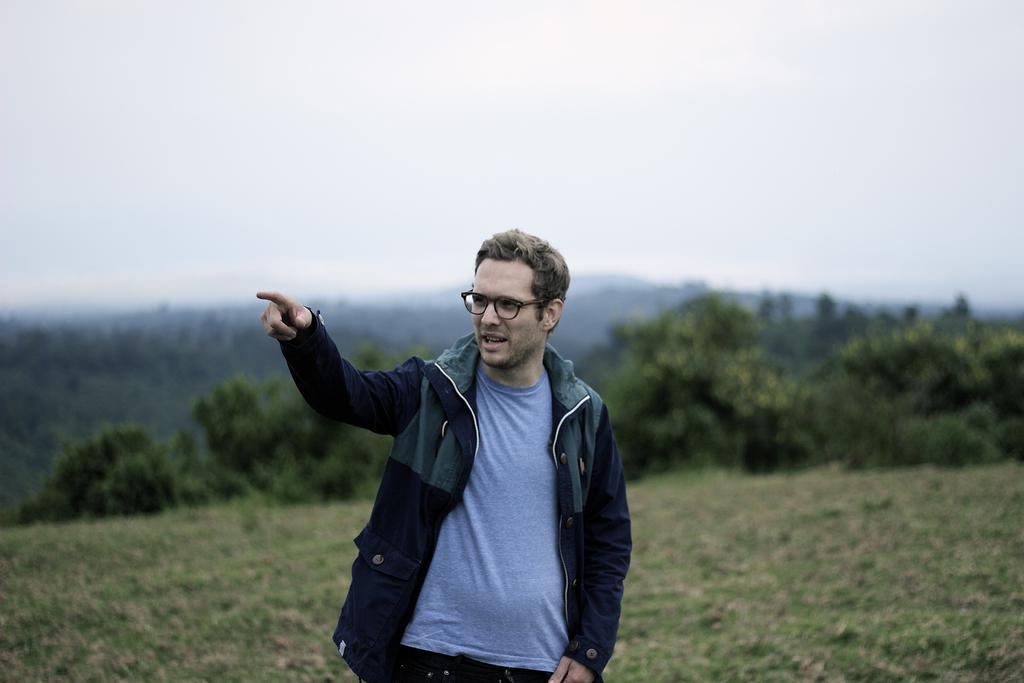Can you describe this image briefly? In this picture there is a man who is wearing goggles, jacket, t-shirt and trouser. He is standing on the farmland. In the background we can see the mountains and many trees. At the top we can see sky and clouds. At the bottom left we can see the grass. 